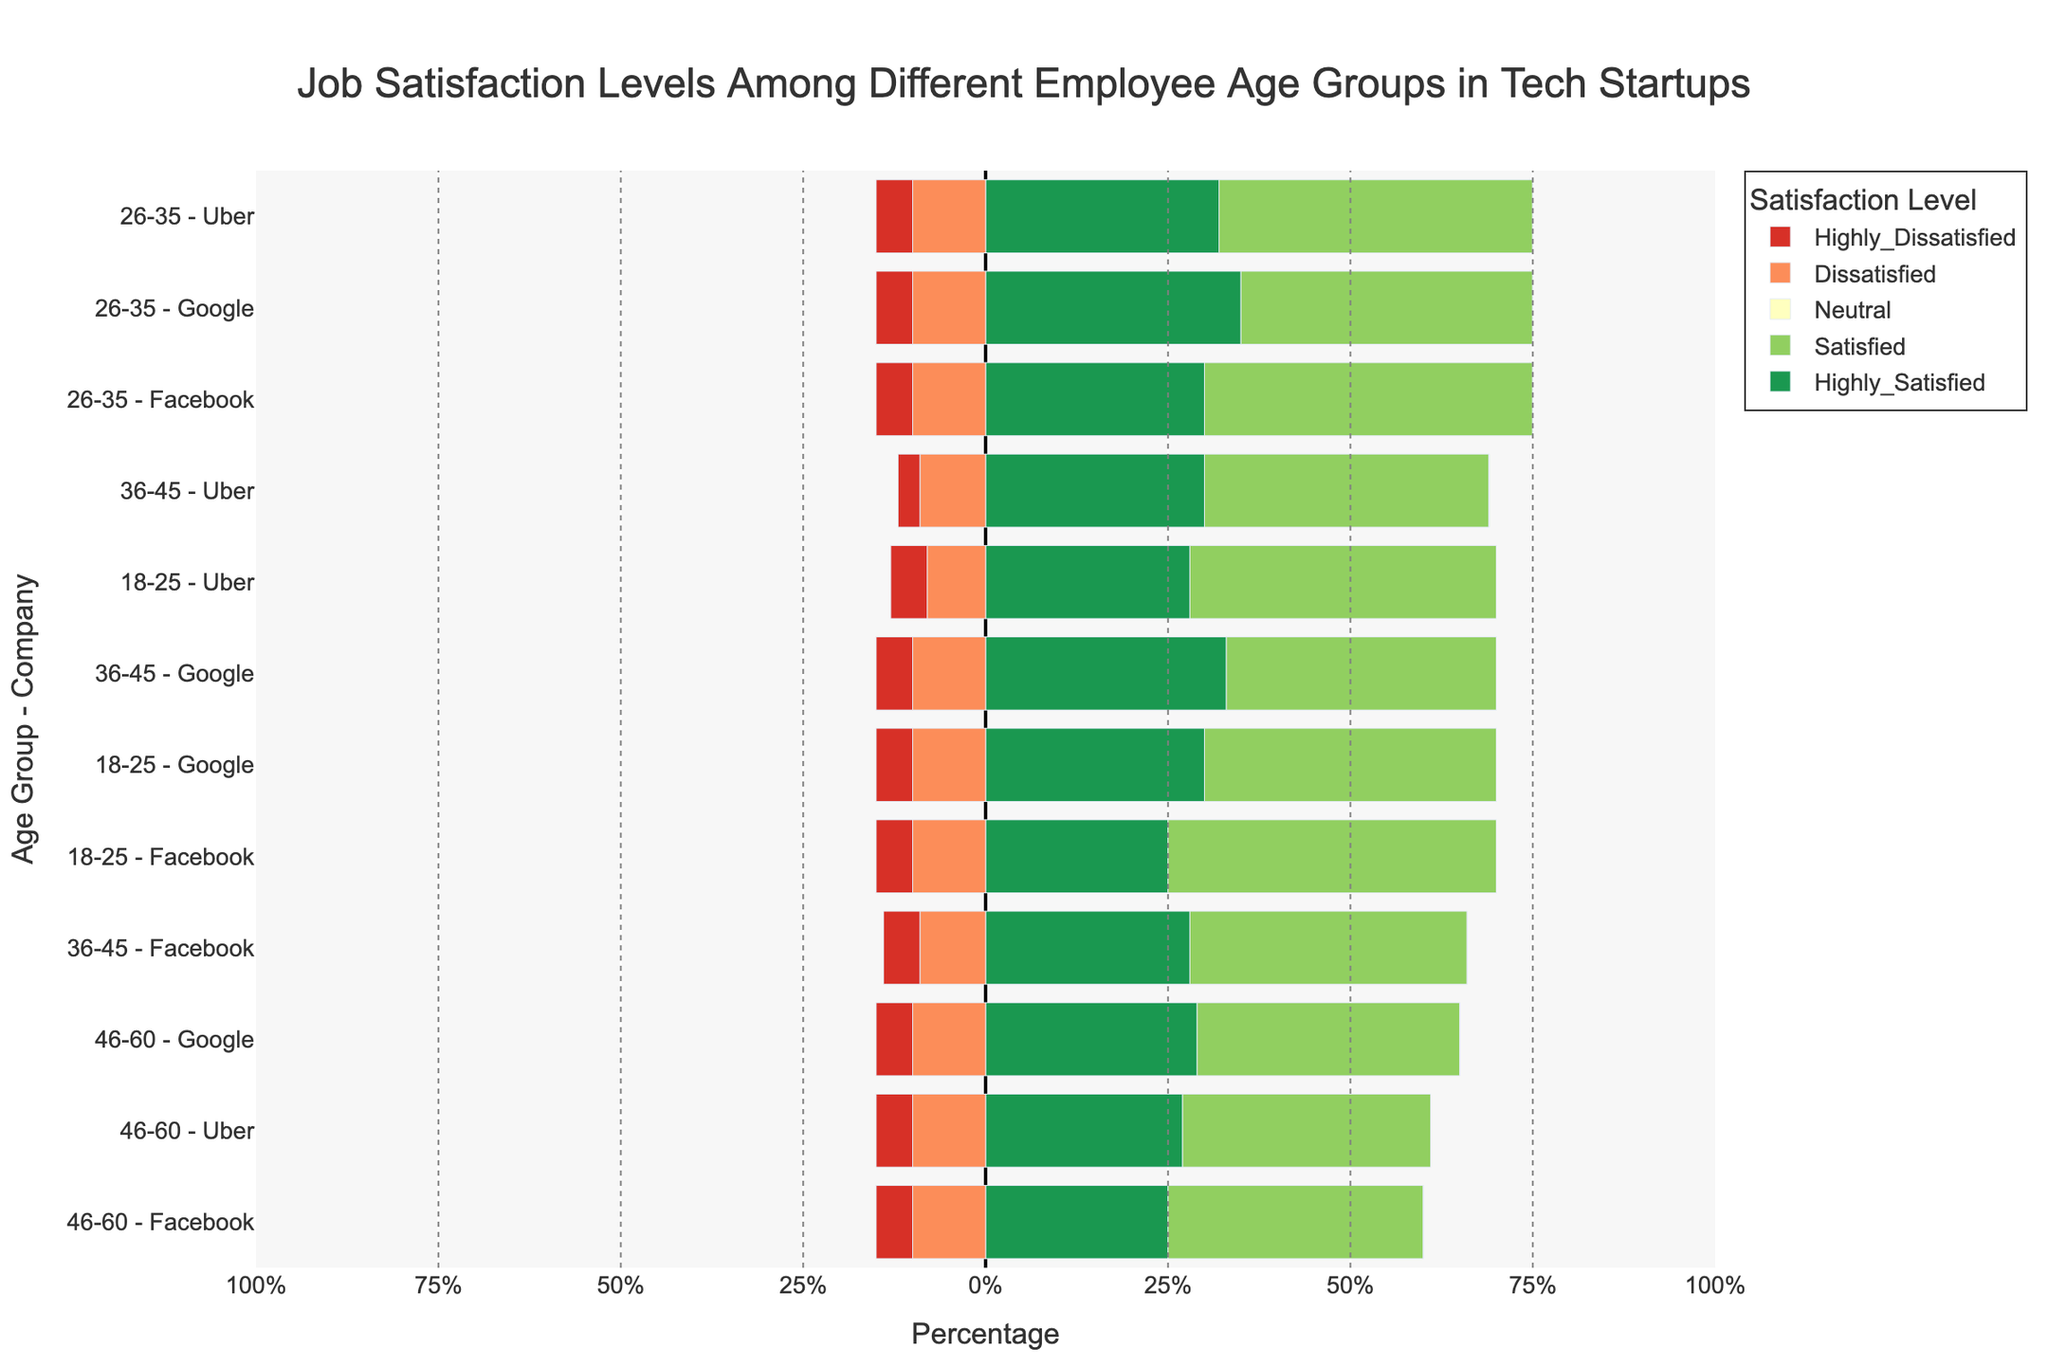Which age group at Google has the highest combined satisfaction (Highly Satisfied + Satisfied)? To find the combined satisfaction, sum the percentages of "Highly Satisfied" and "Satisfied" for each age group at Google. The highest value will identify the age group with the highest combined satisfaction. For 18-25: 30+40=70%, for 26-35: 35+40=75%, for 36-45: 33+37=70%, for 46-60: 29+36=65%. The 26-35 age group has the highest combined satisfaction of 75%.
Answer: 26-35 Which company has the highest percentage of highly dissatisfied employees in the 36-45 age group? Compare the percentage of Highly Dissatisfied employees in the 36-45 age group for each company. For 36-45 age group: Google=5%, Facebook=5%, Uber=3%. Both Google and Facebook have the highest percentage of 5%.
Answer: Google and Facebook Does the 18-25 age group at Facebook have more or fewer satisfied employees compared to those who are neutral? Compare the percentages of Satisfied and Neutral employees in the 18-25 age group at Facebook. Satisfied=45%, Neutral=15%. Since 45% (Satisfied) is greater than 15% (Neutral), the 18-25 age group at Facebook has more satisfied employees.
Answer: More What is the total percentage of dissatisfied and highly dissatisfied employees in the 46-60 age group across all companies? Add the percentages of Dissatisfied and Highly Dissatisfied employees for 46-60 in Google, Facebook, and Uber. Google: 10+5=15%, Facebook: 10+5=15%, Uber: 10+5=15%. Total = 15%+15%+15%=45%.
Answer: 45% Which age group at Uber has the lowest percentage of neutral employees? Compare the percentage of Neutral employees for each age group at Uber. For age groups: 18-25=17%, 26-35=10%, 36-45=19%, 46-60=24%. The 26-35 age group has the lowest percentage of 10%.
Answer: 26-35 In the 26-35 age group, which company has the highest level of overall dissatisfaction (Dissatisfied + Highly Dissatisfied)? Sum the percentages of Dissatisfied and Highly Dissatisfied employees in the 26-35 age group for each company. Google: 10+5=15%, Facebook: 10+5=15%, Uber: 10+5=15%. All companies have the same level of dissatisfaction at 15%.
Answer: All companies Which company's 36-45 age group has the highest number of extremely satisfied (Highly Satisfied) employees? Compare the percentage of Highly Satisfied employees in the 36-45 age group for each company. Google: 33%, Facebook: 28%, Uber: 30%. Google has the highest percentage of 33%.
Answer: Google For the 46-60 age group, how does the total percentage of neutral employees at Google compare to Uber? Compare the percentage of Neutral employees in the 46-60 age group for Google and Uber. Google=20%, Uber=24%. Since 20% (Google) is less than 24% (Uber), Google has a smaller percentage of Neutral employees.
Answer: Less 